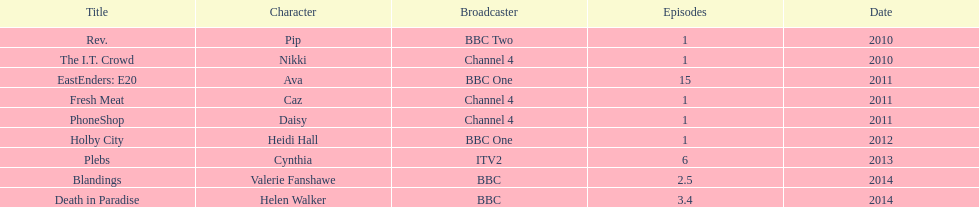What is the count of titles that have 5 episodes or more? 2. 